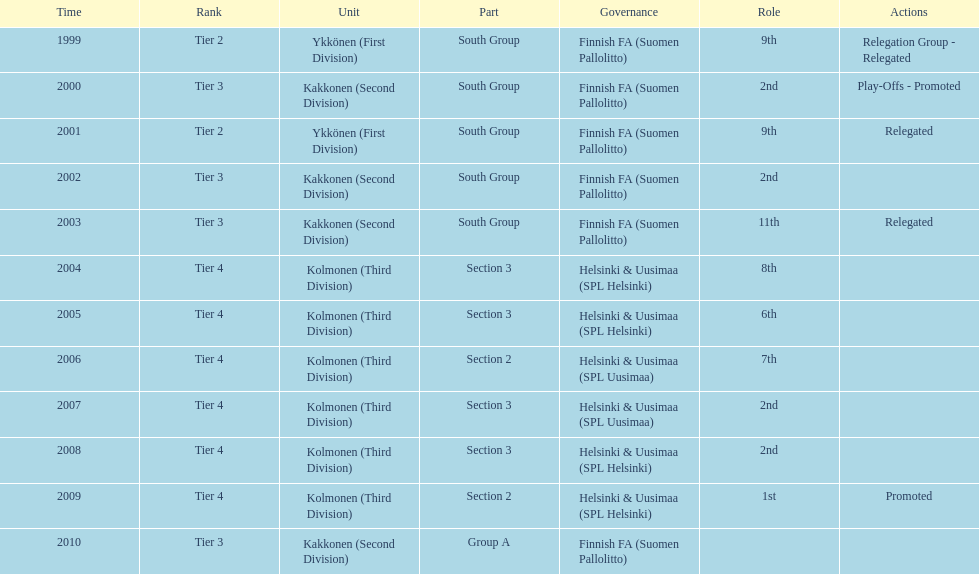Which was the only kolmonen whose movements were promoted? 2009. 